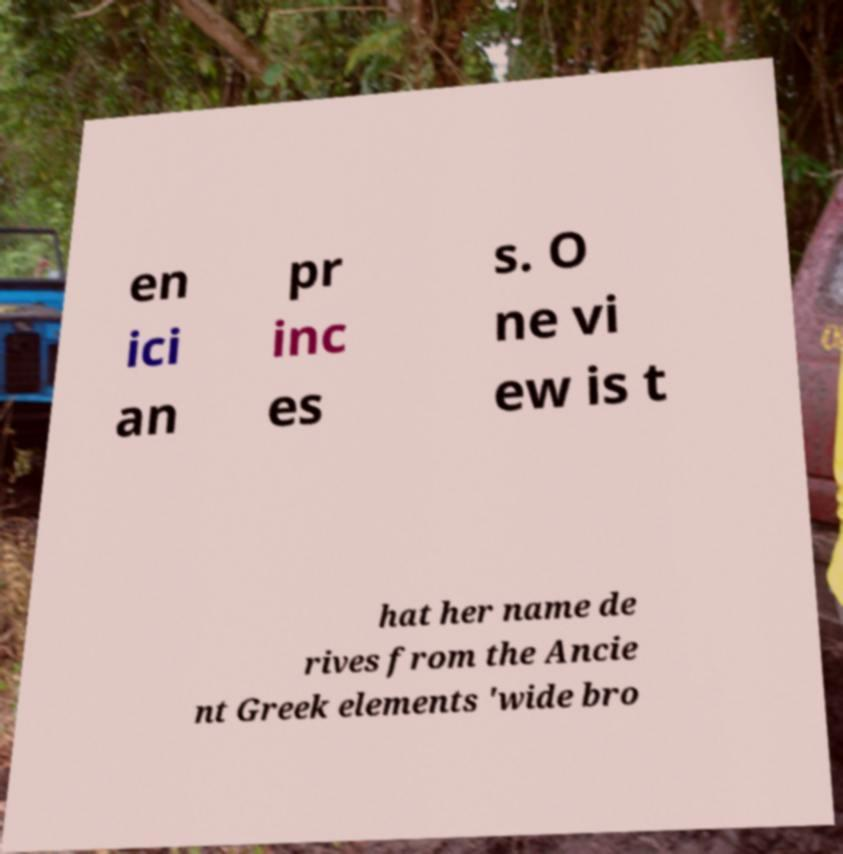For documentation purposes, I need the text within this image transcribed. Could you provide that? en ici an pr inc es s. O ne vi ew is t hat her name de rives from the Ancie nt Greek elements 'wide bro 